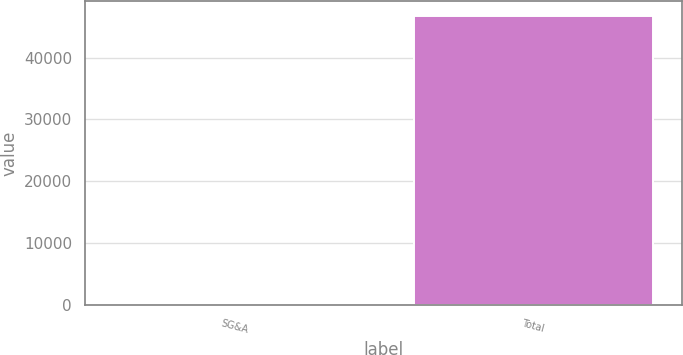Convert chart. <chart><loc_0><loc_0><loc_500><loc_500><bar_chart><fcel>SG&A<fcel>Total<nl><fcel>38<fcel>46786<nl></chart> 